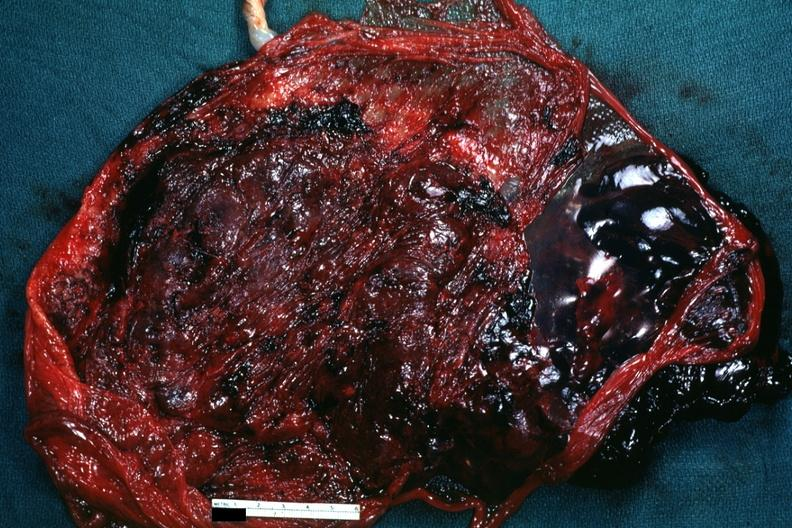what is present?
Answer the question using a single word or phrase. Female reproductive 